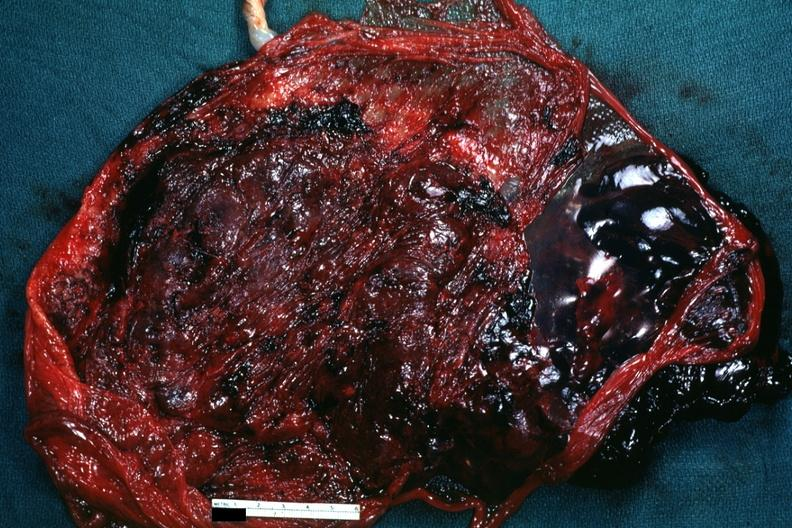what is present?
Answer the question using a single word or phrase. Female reproductive 